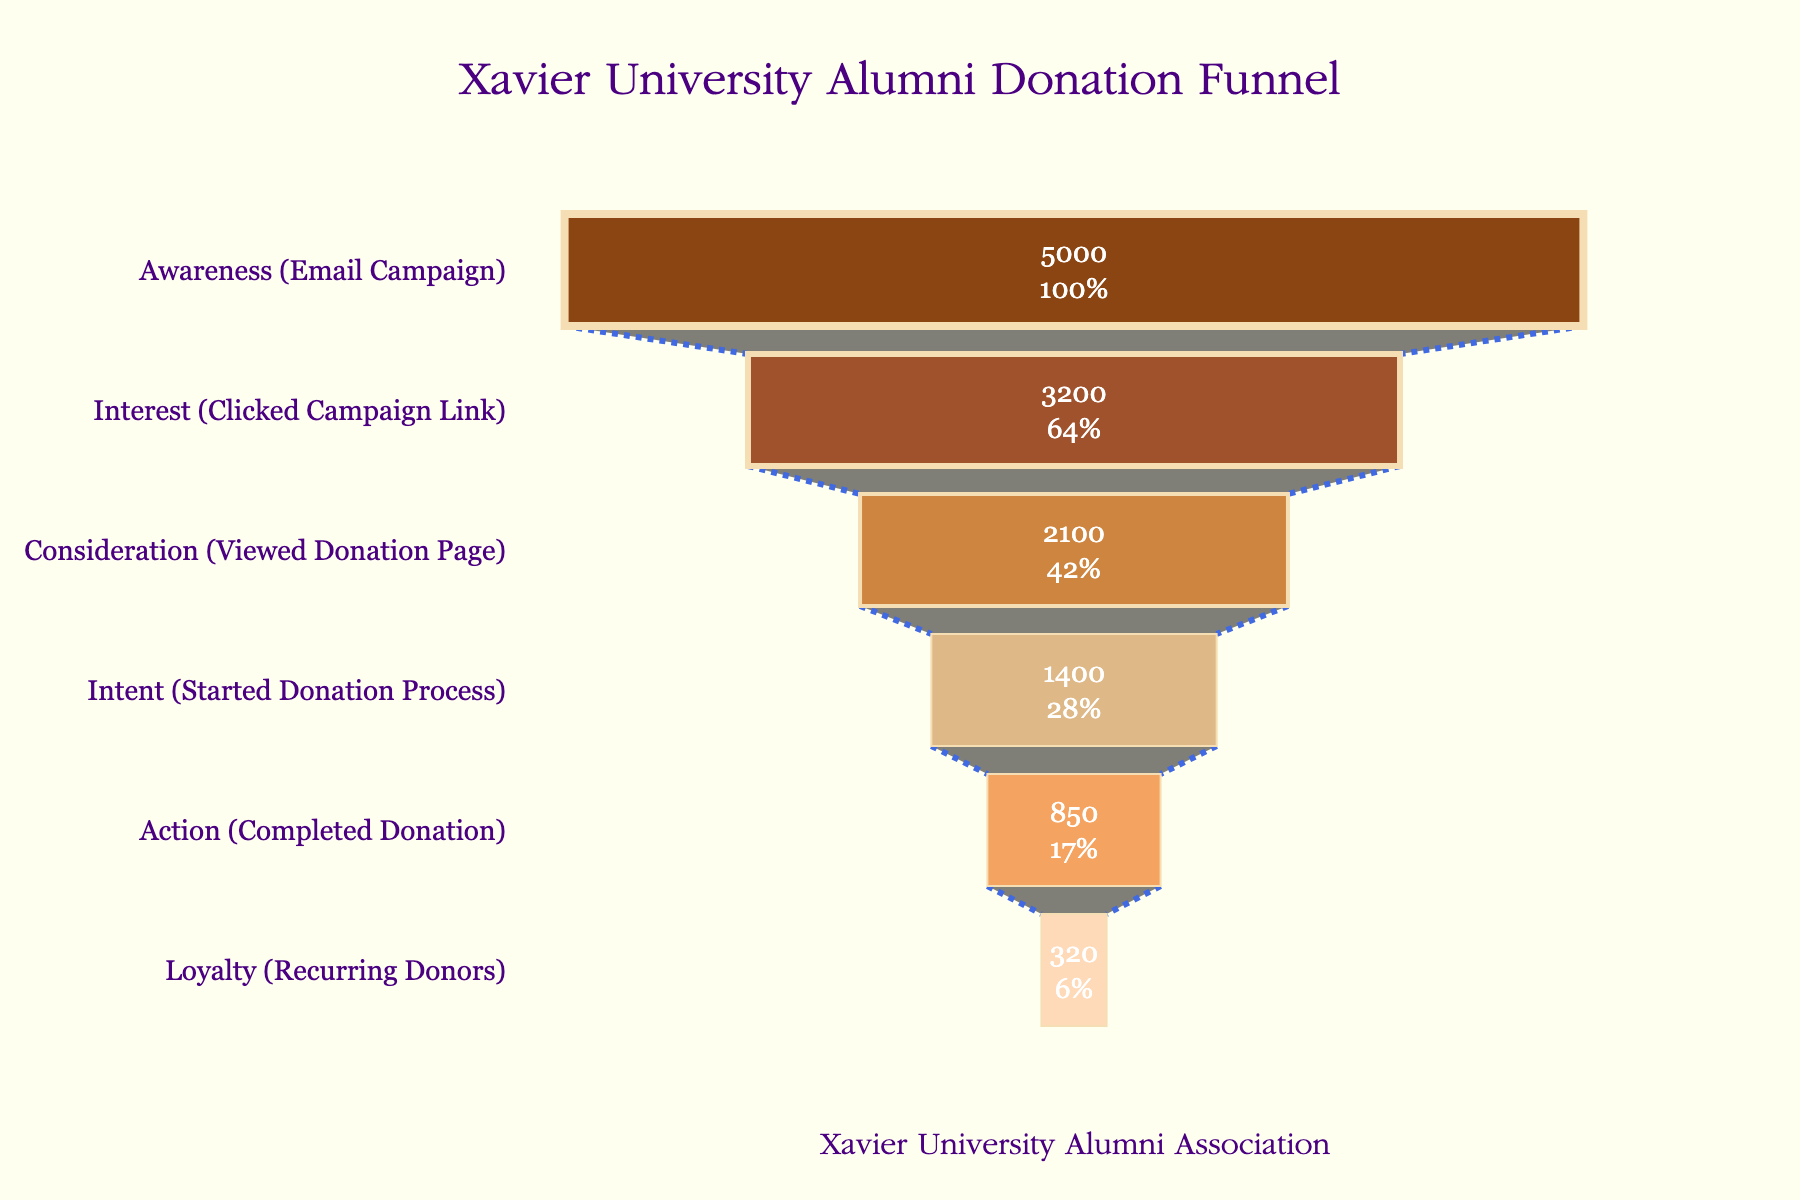What is the title of the funnel chart? The title is displayed at the top center of the chart. It is written in a larger font size and in a distinct color.
Answer: Xavier University Alumni Donation Funnel How many alumni are at the "Action (Completed Donation)" stage? We look at the "Action (Completed Donation)" stage on the funnel chart and find the number next to it.
Answer: 850 By how much does the number of alumni decrease from the "Interest (Clicked Campaign Link)" stage to the "Consideration (Viewed Donation Page)" stage? Subtract the number of alumni at the "Consideration (Viewed Donation Page)" stage from the number at the "Interest (Clicked Campaign Link)" stage: 3200 - 2100.
Answer: 1100 Which stage has the smallest number of alumni and what is that number? Identify the stage with the lowest value on the funnel chart, which is the "Loyalty (Recurring Donors)" stage. The number next to it shows the value.
Answer: Loyalty (Recurring Donors), 320 What percentage of alumni remain from the "Consideration (Viewed Donation Page)" stage to the "Action (Completed Donation)" stage? Divide the number of alumni at the "Action (Completed Donation)" stage by the number at the "Consideration (Viewed Donation Page)" stage and multiply by 100 to convert to a percentage: (850 / 2100) * 100.
Answer: ~40.5% What is the difference between the number of alumni in the "Awareness (Email Campaign)" stage and the "Loyalty (Recurring Donors)" stage? Subtract the number of alumni at the "Loyalty (Recurring Donors)" stage from the number at the "Awareness (Email Campaign)" stage: 5000 - 320.
Answer: 4680 Approximately what fraction of the total alumni in the "Awareness (Email Campaign)" stage completes the donation ("Action" stage)? Divide the number of alumni at the "Action (Completed Donation)" stage by the number at the "Awareness (Email Campaign)" stage: 850 / 5000.
Answer: 0.17 How many more alumni started the donation process ("Intent" stage) compared to those who completed the donation ("Action" stage)? Subtract the number of alumni at the "Action (Completed Donation)" stage from the number at the "Intent (Started Donation Process)" stage: 1400 - 850.
Answer: 550 